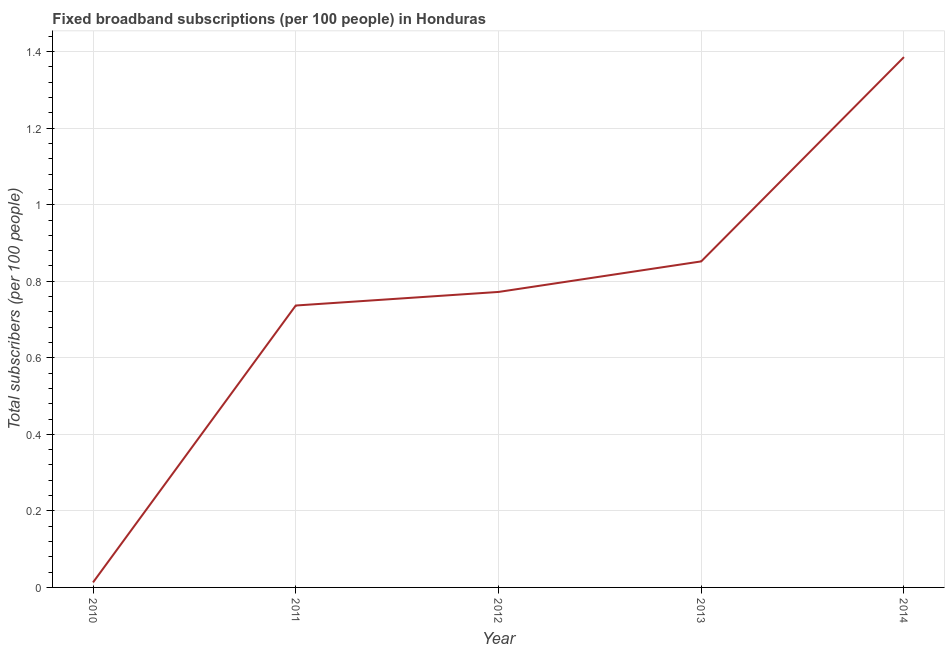What is the total number of fixed broadband subscriptions in 2012?
Ensure brevity in your answer.  0.77. Across all years, what is the maximum total number of fixed broadband subscriptions?
Your answer should be very brief. 1.39. Across all years, what is the minimum total number of fixed broadband subscriptions?
Offer a very short reply. 0.01. In which year was the total number of fixed broadband subscriptions maximum?
Give a very brief answer. 2014. In which year was the total number of fixed broadband subscriptions minimum?
Your answer should be very brief. 2010. What is the sum of the total number of fixed broadband subscriptions?
Offer a terse response. 3.76. What is the difference between the total number of fixed broadband subscriptions in 2011 and 2014?
Offer a terse response. -0.65. What is the average total number of fixed broadband subscriptions per year?
Offer a terse response. 0.75. What is the median total number of fixed broadband subscriptions?
Keep it short and to the point. 0.77. In how many years, is the total number of fixed broadband subscriptions greater than 0.4 ?
Ensure brevity in your answer.  4. What is the ratio of the total number of fixed broadband subscriptions in 2011 to that in 2014?
Keep it short and to the point. 0.53. Is the difference between the total number of fixed broadband subscriptions in 2012 and 2014 greater than the difference between any two years?
Ensure brevity in your answer.  No. What is the difference between the highest and the second highest total number of fixed broadband subscriptions?
Ensure brevity in your answer.  0.53. Is the sum of the total number of fixed broadband subscriptions in 2010 and 2012 greater than the maximum total number of fixed broadband subscriptions across all years?
Provide a short and direct response. No. What is the difference between the highest and the lowest total number of fixed broadband subscriptions?
Make the answer very short. 1.37. In how many years, is the total number of fixed broadband subscriptions greater than the average total number of fixed broadband subscriptions taken over all years?
Offer a very short reply. 3. What is the difference between two consecutive major ticks on the Y-axis?
Your response must be concise. 0.2. Does the graph contain any zero values?
Ensure brevity in your answer.  No. What is the title of the graph?
Make the answer very short. Fixed broadband subscriptions (per 100 people) in Honduras. What is the label or title of the X-axis?
Your answer should be compact. Year. What is the label or title of the Y-axis?
Your answer should be compact. Total subscribers (per 100 people). What is the Total subscribers (per 100 people) of 2010?
Keep it short and to the point. 0.01. What is the Total subscribers (per 100 people) of 2011?
Provide a succinct answer. 0.74. What is the Total subscribers (per 100 people) in 2012?
Give a very brief answer. 0.77. What is the Total subscribers (per 100 people) of 2013?
Provide a short and direct response. 0.85. What is the Total subscribers (per 100 people) in 2014?
Provide a short and direct response. 1.39. What is the difference between the Total subscribers (per 100 people) in 2010 and 2011?
Your response must be concise. -0.72. What is the difference between the Total subscribers (per 100 people) in 2010 and 2012?
Offer a very short reply. -0.76. What is the difference between the Total subscribers (per 100 people) in 2010 and 2013?
Your answer should be compact. -0.84. What is the difference between the Total subscribers (per 100 people) in 2010 and 2014?
Offer a very short reply. -1.37. What is the difference between the Total subscribers (per 100 people) in 2011 and 2012?
Provide a succinct answer. -0.04. What is the difference between the Total subscribers (per 100 people) in 2011 and 2013?
Offer a terse response. -0.12. What is the difference between the Total subscribers (per 100 people) in 2011 and 2014?
Your answer should be very brief. -0.65. What is the difference between the Total subscribers (per 100 people) in 2012 and 2013?
Provide a succinct answer. -0.08. What is the difference between the Total subscribers (per 100 people) in 2012 and 2014?
Provide a short and direct response. -0.61. What is the difference between the Total subscribers (per 100 people) in 2013 and 2014?
Your answer should be very brief. -0.53. What is the ratio of the Total subscribers (per 100 people) in 2010 to that in 2011?
Your response must be concise. 0.02. What is the ratio of the Total subscribers (per 100 people) in 2010 to that in 2012?
Make the answer very short. 0.02. What is the ratio of the Total subscribers (per 100 people) in 2010 to that in 2013?
Your answer should be very brief. 0.01. What is the ratio of the Total subscribers (per 100 people) in 2010 to that in 2014?
Keep it short and to the point. 0.01. What is the ratio of the Total subscribers (per 100 people) in 2011 to that in 2012?
Your answer should be compact. 0.95. What is the ratio of the Total subscribers (per 100 people) in 2011 to that in 2013?
Offer a very short reply. 0.86. What is the ratio of the Total subscribers (per 100 people) in 2011 to that in 2014?
Keep it short and to the point. 0.53. What is the ratio of the Total subscribers (per 100 people) in 2012 to that in 2013?
Make the answer very short. 0.91. What is the ratio of the Total subscribers (per 100 people) in 2012 to that in 2014?
Give a very brief answer. 0.56. What is the ratio of the Total subscribers (per 100 people) in 2013 to that in 2014?
Provide a succinct answer. 0.61. 